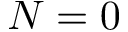Convert formula to latex. <formula><loc_0><loc_0><loc_500><loc_500>N = 0</formula> 